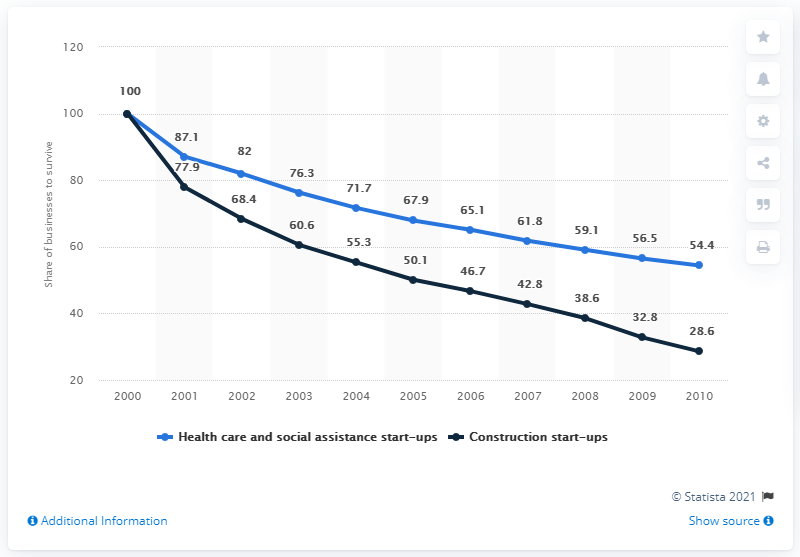Point out several critical features in this image. In 2000, start-ups were established. In 2000, the black line graph reached its highest peak. In 2010, 28.6% of construction businesses were still operational. The difference between the highest value of healthcare start-ups and the lowest value of construction start-ups is 71.4%. In 2010, 54.4% of health care and social assistance businesses were still operating. 